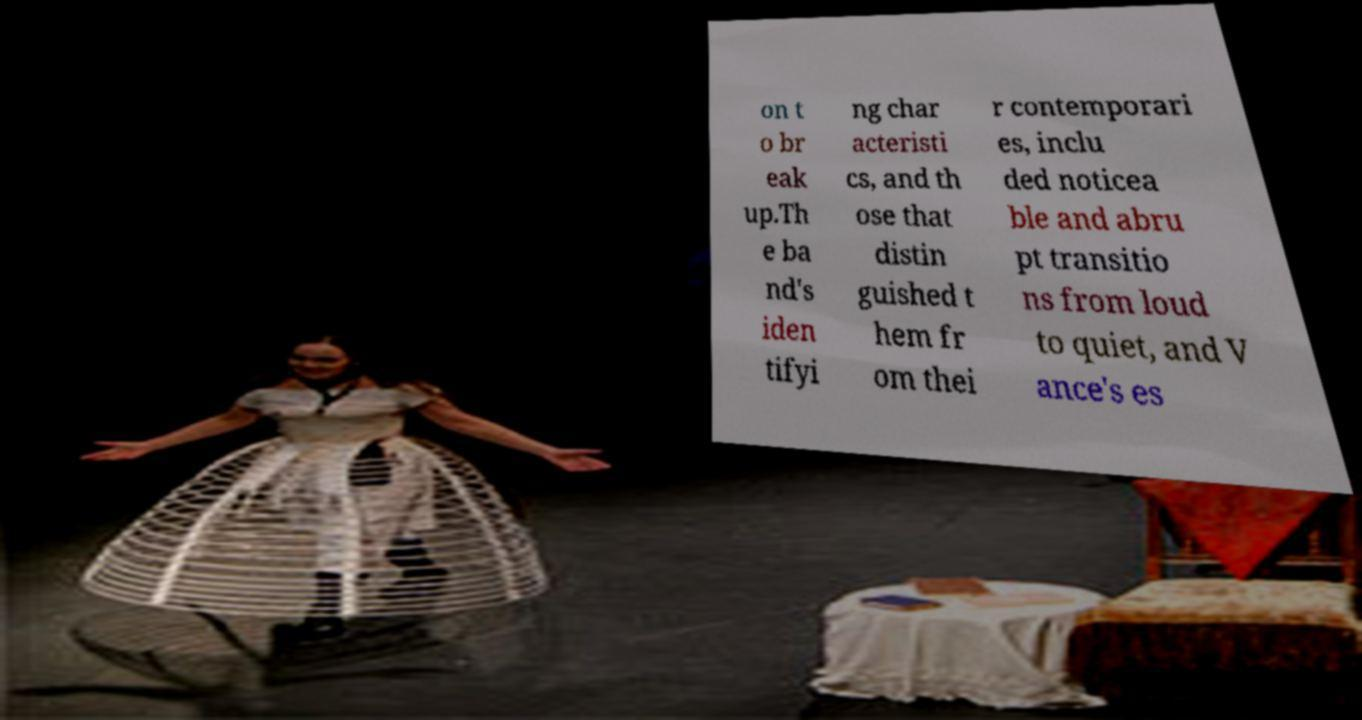What messages or text are displayed in this image? I need them in a readable, typed format. on t o br eak up.Th e ba nd's iden tifyi ng char acteristi cs, and th ose that distin guished t hem fr om thei r contemporari es, inclu ded noticea ble and abru pt transitio ns from loud to quiet, and V ance's es 